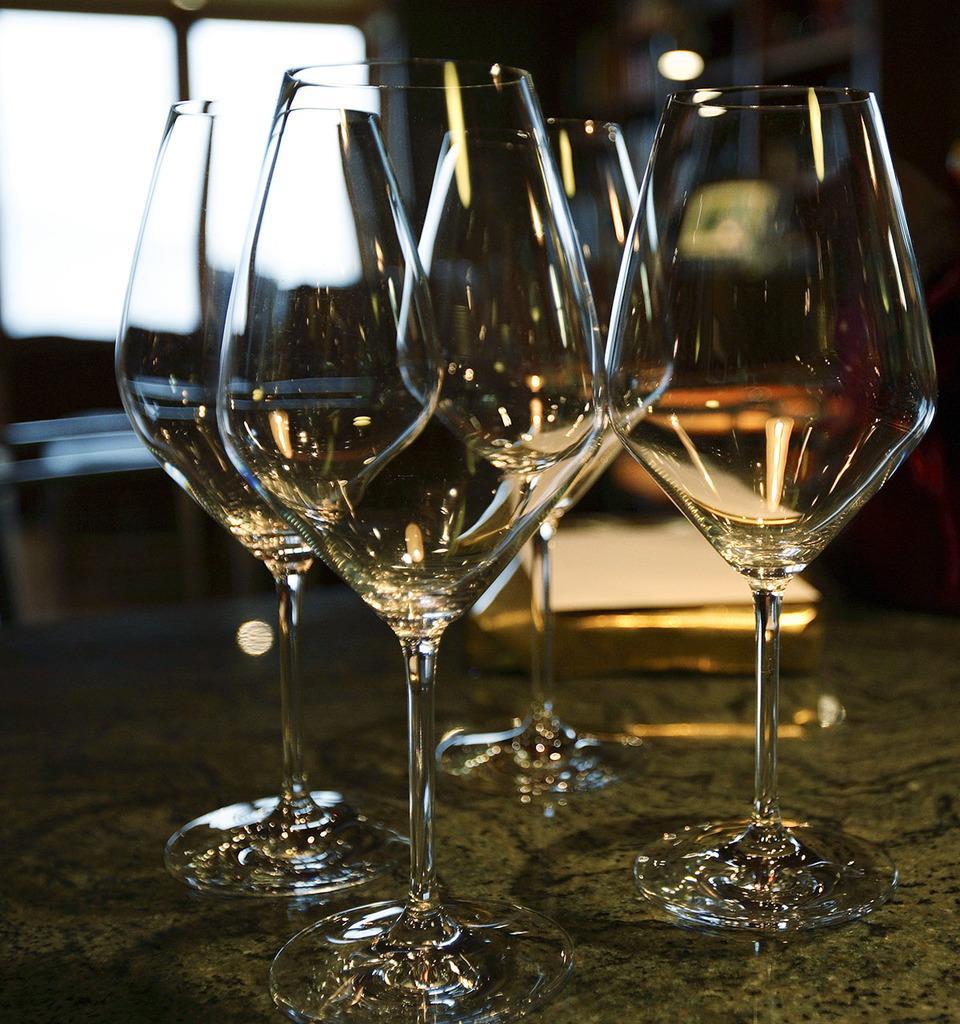Describe this image in one or two sentences. In this picture I can see the wine glasses, at the top there is a light. 